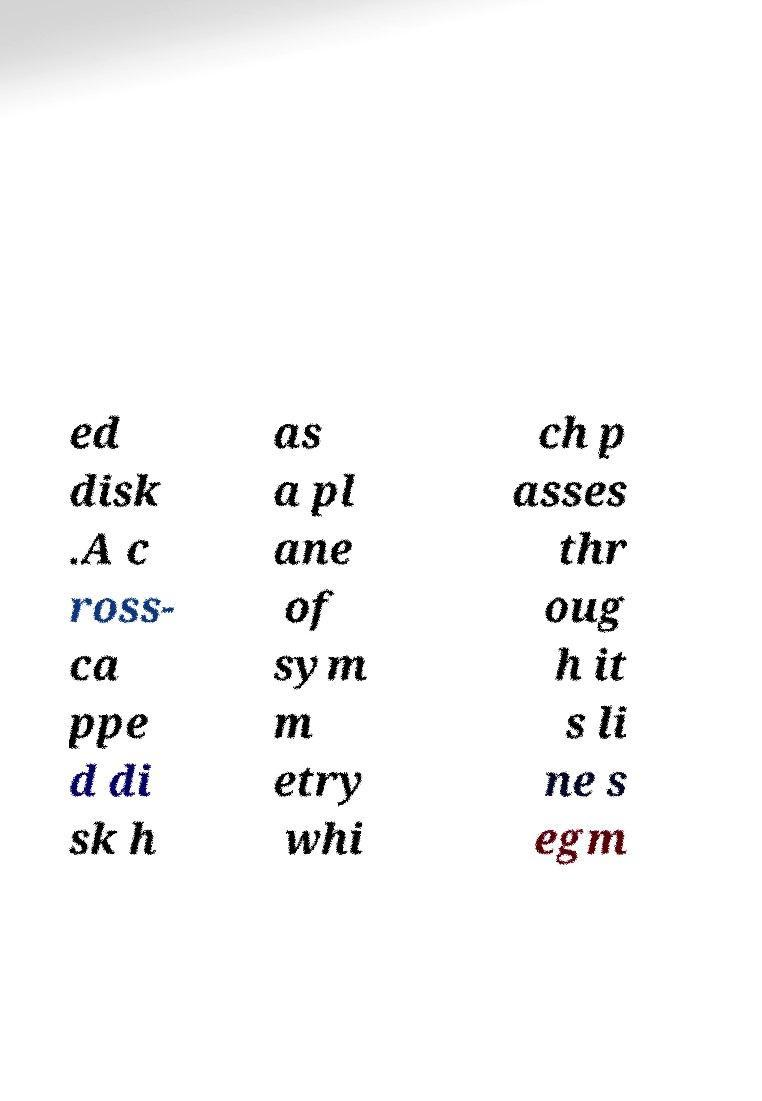Can you read and provide the text displayed in the image?This photo seems to have some interesting text. Can you extract and type it out for me? ed disk .A c ross- ca ppe d di sk h as a pl ane of sym m etry whi ch p asses thr oug h it s li ne s egm 